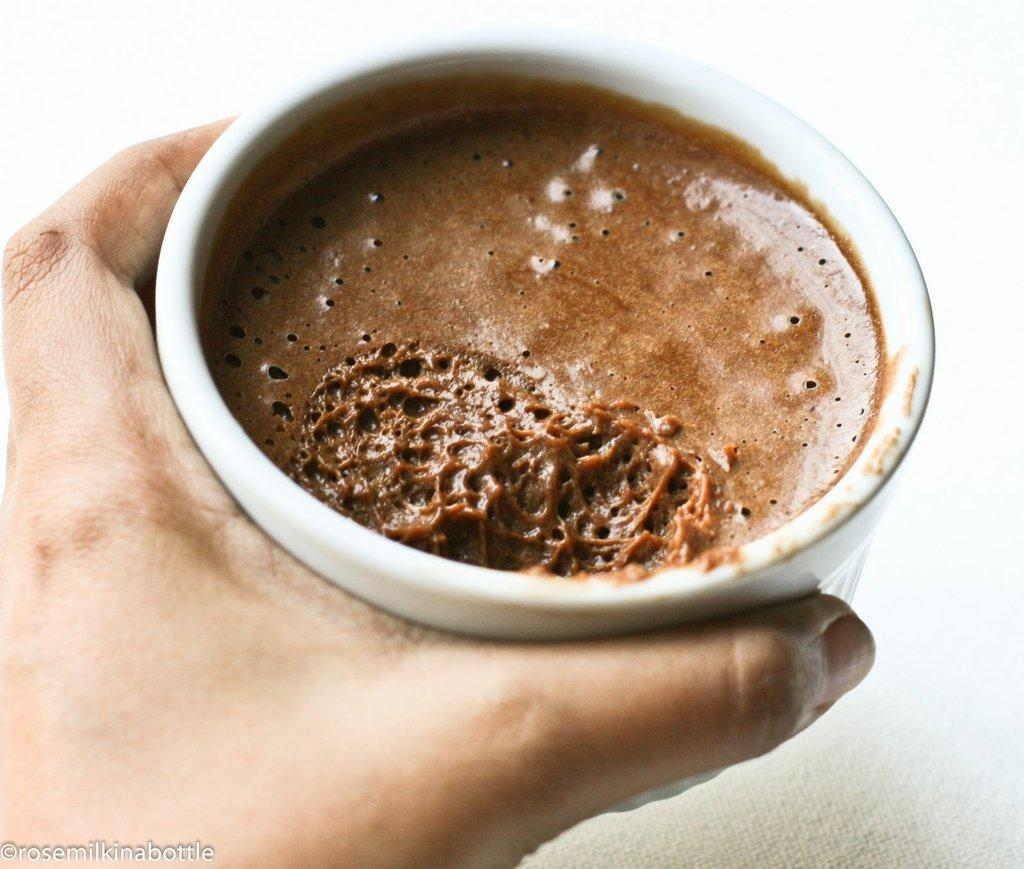What is being held in the person's hand in the image? There is a person's hand holding a cup in the image. What else can be seen at the bottom of the image? There is text visible at the bottom of the image. What type of toys can be seen in the person's hand in the image? There are no toys present in the image; it features a person's hand holding a cup. What is the name of the person's son in the image? There is no reference to a son in the image. 